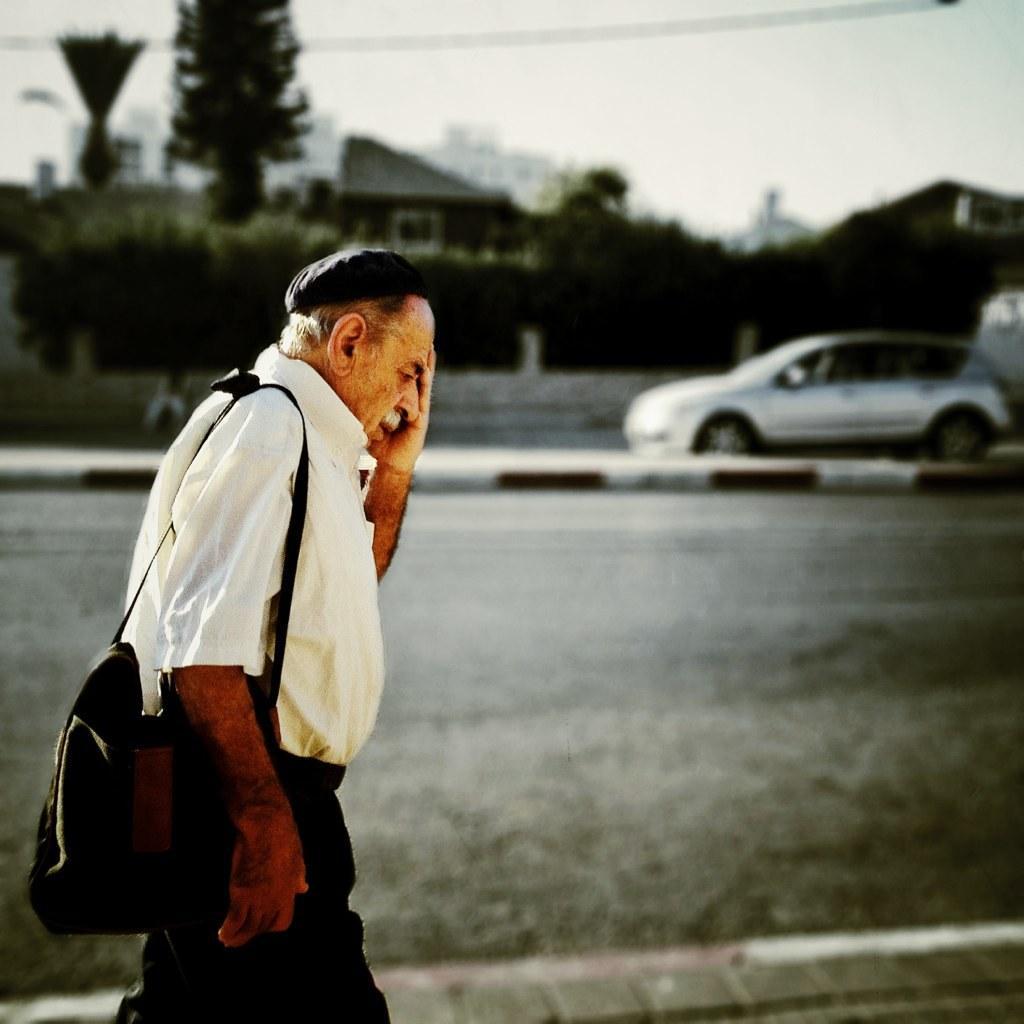Please provide a concise description of this image. In this image on the left, there is a man, he wears a shirt, trouser, bag, that, he is walking. In the background there are trees, car, cables, house, road and sky. 